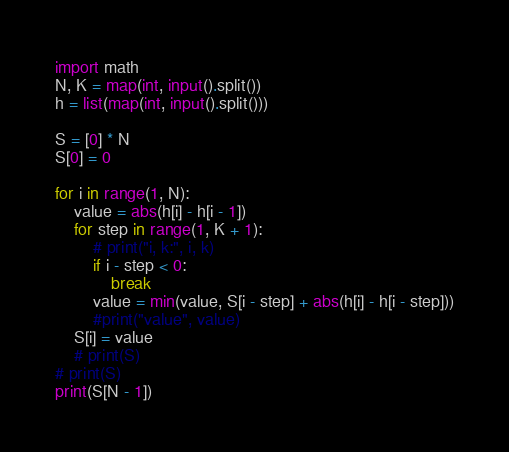<code> <loc_0><loc_0><loc_500><loc_500><_Python_>import math
N, K = map(int, input().split())
h = list(map(int, input().split()))

S = [0] * N
S[0] = 0

for i in range(1, N):
    value = abs(h[i] - h[i - 1])
    for step in range(1, K + 1):
        # print("i, k:", i, k)
        if i - step < 0:
            break
        value = min(value, S[i - step] + abs(h[i] - h[i - step]))
        #print("value", value)
    S[i] = value
    # print(S)
# print(S)
print(S[N - 1])
</code> 